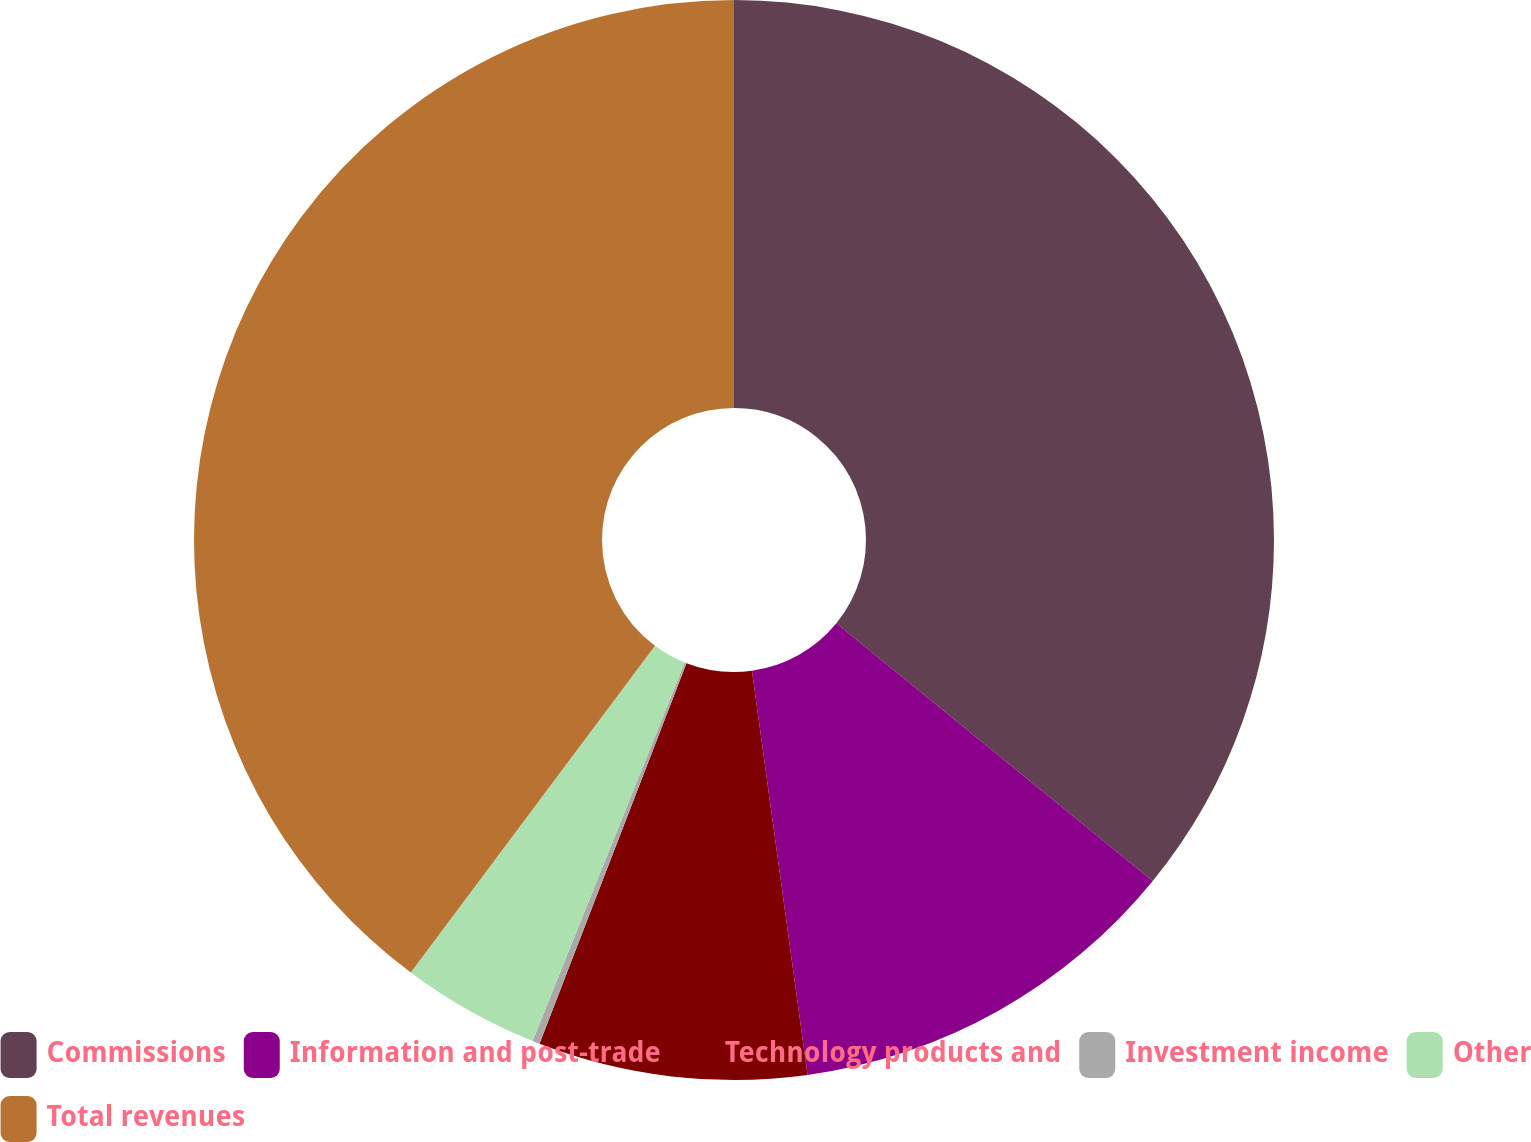Convert chart. <chart><loc_0><loc_0><loc_500><loc_500><pie_chart><fcel>Commissions<fcel>Information and post-trade<fcel>Technology products and<fcel>Investment income<fcel>Other<fcel>Total revenues<nl><fcel>35.88%<fcel>11.95%<fcel>8.04%<fcel>0.22%<fcel>4.13%<fcel>39.79%<nl></chart> 